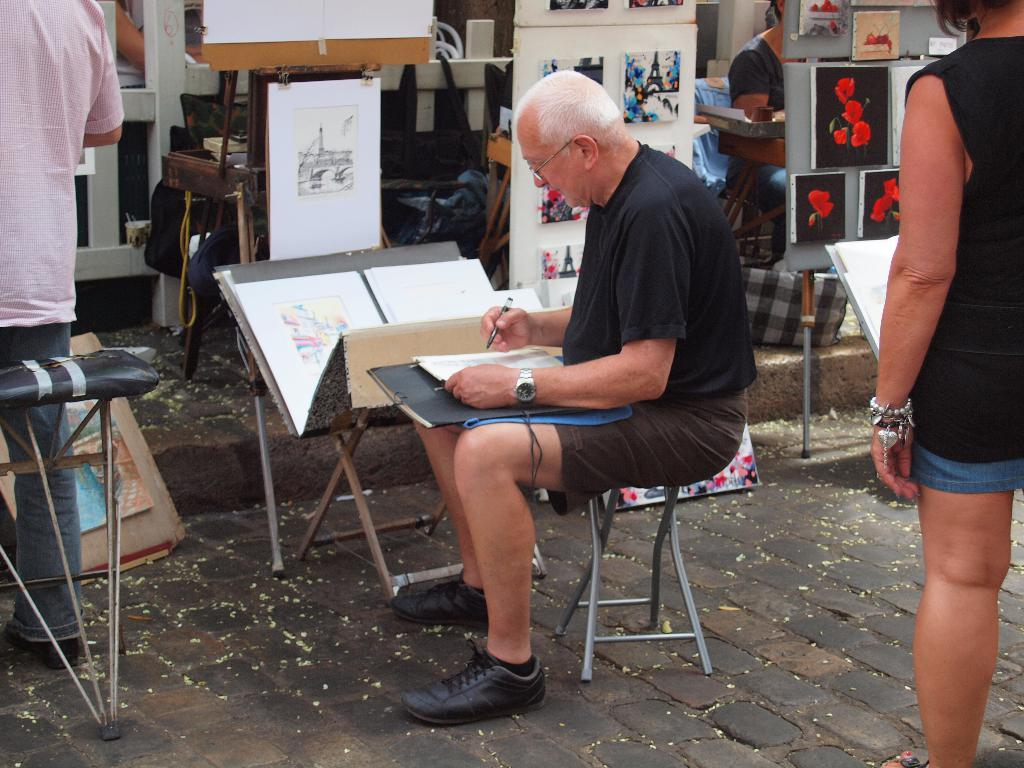What is the man in the image doing? The man is sitting on a stool in the image. What is the man holding in the image? The man is holding a pen in the image. What might the man be about to do with the pen? The man might be about to write on the paper in the image. Can you describe the people visible in the image? There are people visible in the image, but their specific actions or features are not mentioned in the provided facts. What is displayed on the board in the image? Art is displayed on a board in the image. How many cows are visible in the image? There are no cows visible in the image; it features a man sitting on a stool, holding a pen, and art displayed on a board. What type of vegetable is being used as a prop in the image? There is no vegetable present in the image. 